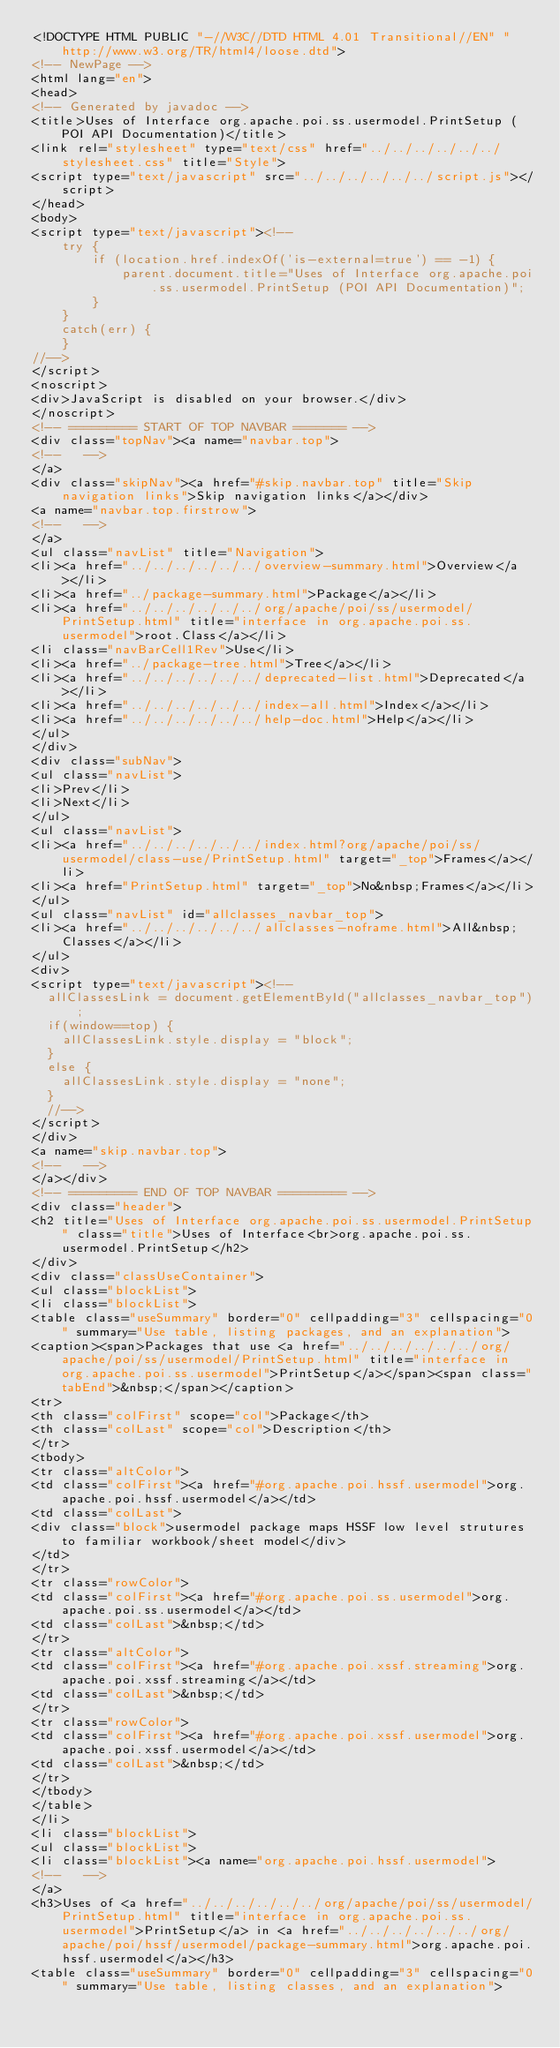<code> <loc_0><loc_0><loc_500><loc_500><_HTML_><!DOCTYPE HTML PUBLIC "-//W3C//DTD HTML 4.01 Transitional//EN" "http://www.w3.org/TR/html4/loose.dtd">
<!-- NewPage -->
<html lang="en">
<head>
<!-- Generated by javadoc -->
<title>Uses of Interface org.apache.poi.ss.usermodel.PrintSetup (POI API Documentation)</title>
<link rel="stylesheet" type="text/css" href="../../../../../../stylesheet.css" title="Style">
<script type="text/javascript" src="../../../../../../script.js"></script>
</head>
<body>
<script type="text/javascript"><!--
    try {
        if (location.href.indexOf('is-external=true') == -1) {
            parent.document.title="Uses of Interface org.apache.poi.ss.usermodel.PrintSetup (POI API Documentation)";
        }
    }
    catch(err) {
    }
//-->
</script>
<noscript>
<div>JavaScript is disabled on your browser.</div>
</noscript>
<!-- ========= START OF TOP NAVBAR ======= -->
<div class="topNav"><a name="navbar.top">
<!--   -->
</a>
<div class="skipNav"><a href="#skip.navbar.top" title="Skip navigation links">Skip navigation links</a></div>
<a name="navbar.top.firstrow">
<!--   -->
</a>
<ul class="navList" title="Navigation">
<li><a href="../../../../../../overview-summary.html">Overview</a></li>
<li><a href="../package-summary.html">Package</a></li>
<li><a href="../../../../../../org/apache/poi/ss/usermodel/PrintSetup.html" title="interface in org.apache.poi.ss.usermodel">root.Class</a></li>
<li class="navBarCell1Rev">Use</li>
<li><a href="../package-tree.html">Tree</a></li>
<li><a href="../../../../../../deprecated-list.html">Deprecated</a></li>
<li><a href="../../../../../../index-all.html">Index</a></li>
<li><a href="../../../../../../help-doc.html">Help</a></li>
</ul>
</div>
<div class="subNav">
<ul class="navList">
<li>Prev</li>
<li>Next</li>
</ul>
<ul class="navList">
<li><a href="../../../../../../index.html?org/apache/poi/ss/usermodel/class-use/PrintSetup.html" target="_top">Frames</a></li>
<li><a href="PrintSetup.html" target="_top">No&nbsp;Frames</a></li>
</ul>
<ul class="navList" id="allclasses_navbar_top">
<li><a href="../../../../../../allclasses-noframe.html">All&nbsp;Classes</a></li>
</ul>
<div>
<script type="text/javascript"><!--
  allClassesLink = document.getElementById("allclasses_navbar_top");
  if(window==top) {
    allClassesLink.style.display = "block";
  }
  else {
    allClassesLink.style.display = "none";
  }
  //-->
</script>
</div>
<a name="skip.navbar.top">
<!--   -->
</a></div>
<!-- ========= END OF TOP NAVBAR ========= -->
<div class="header">
<h2 title="Uses of Interface org.apache.poi.ss.usermodel.PrintSetup" class="title">Uses of Interface<br>org.apache.poi.ss.usermodel.PrintSetup</h2>
</div>
<div class="classUseContainer">
<ul class="blockList">
<li class="blockList">
<table class="useSummary" border="0" cellpadding="3" cellspacing="0" summary="Use table, listing packages, and an explanation">
<caption><span>Packages that use <a href="../../../../../../org/apache/poi/ss/usermodel/PrintSetup.html" title="interface in org.apache.poi.ss.usermodel">PrintSetup</a></span><span class="tabEnd">&nbsp;</span></caption>
<tr>
<th class="colFirst" scope="col">Package</th>
<th class="colLast" scope="col">Description</th>
</tr>
<tbody>
<tr class="altColor">
<td class="colFirst"><a href="#org.apache.poi.hssf.usermodel">org.apache.poi.hssf.usermodel</a></td>
<td class="colLast">
<div class="block">usermodel package maps HSSF low level strutures to familiar workbook/sheet model</div>
</td>
</tr>
<tr class="rowColor">
<td class="colFirst"><a href="#org.apache.poi.ss.usermodel">org.apache.poi.ss.usermodel</a></td>
<td class="colLast">&nbsp;</td>
</tr>
<tr class="altColor">
<td class="colFirst"><a href="#org.apache.poi.xssf.streaming">org.apache.poi.xssf.streaming</a></td>
<td class="colLast">&nbsp;</td>
</tr>
<tr class="rowColor">
<td class="colFirst"><a href="#org.apache.poi.xssf.usermodel">org.apache.poi.xssf.usermodel</a></td>
<td class="colLast">&nbsp;</td>
</tr>
</tbody>
</table>
</li>
<li class="blockList">
<ul class="blockList">
<li class="blockList"><a name="org.apache.poi.hssf.usermodel">
<!--   -->
</a>
<h3>Uses of <a href="../../../../../../org/apache/poi/ss/usermodel/PrintSetup.html" title="interface in org.apache.poi.ss.usermodel">PrintSetup</a> in <a href="../../../../../../org/apache/poi/hssf/usermodel/package-summary.html">org.apache.poi.hssf.usermodel</a></h3>
<table class="useSummary" border="0" cellpadding="3" cellspacing="0" summary="Use table, listing classes, and an explanation"></code> 